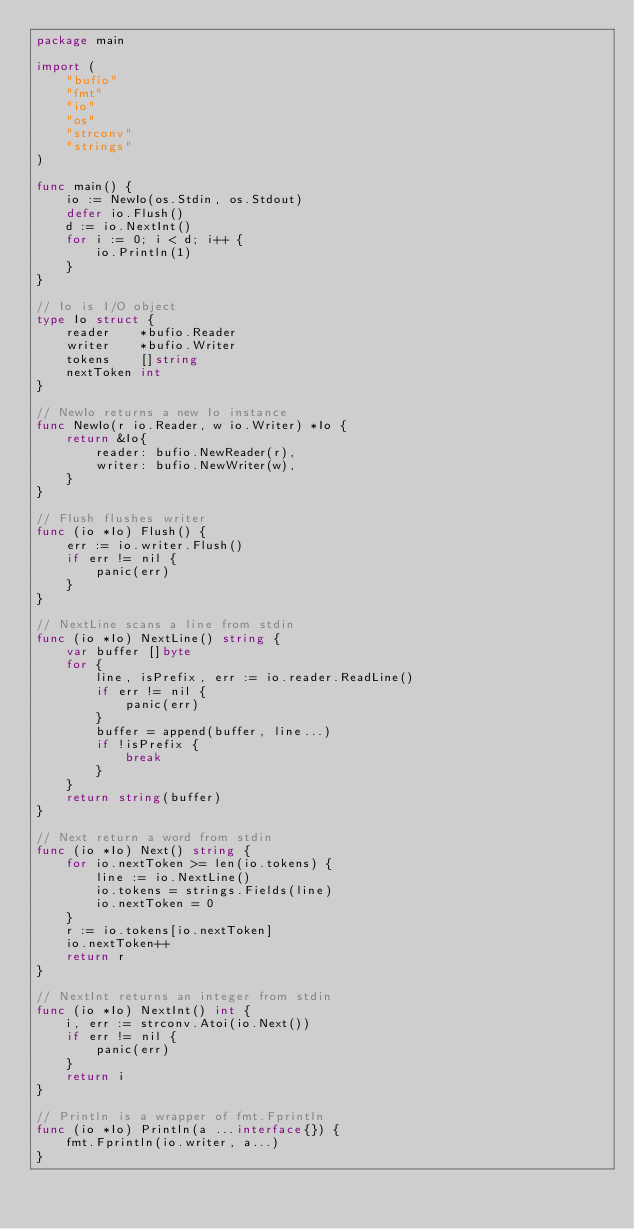Convert code to text. <code><loc_0><loc_0><loc_500><loc_500><_Go_>package main

import (
	"bufio"
	"fmt"
	"io"
	"os"
	"strconv"
	"strings"
)

func main() {
	io := NewIo(os.Stdin, os.Stdout)
	defer io.Flush()
	d := io.NextInt()
	for i := 0; i < d; i++ {
		io.Println(1)
	}
}

// Io is I/O object
type Io struct {
	reader    *bufio.Reader
	writer    *bufio.Writer
	tokens    []string
	nextToken int
}

// NewIo returns a new Io instance
func NewIo(r io.Reader, w io.Writer) *Io {
	return &Io{
		reader: bufio.NewReader(r),
		writer: bufio.NewWriter(w),
	}
}

// Flush flushes writer
func (io *Io) Flush() {
	err := io.writer.Flush()
	if err != nil {
		panic(err)
	}
}

// NextLine scans a line from stdin
func (io *Io) NextLine() string {
	var buffer []byte
	for {
		line, isPrefix, err := io.reader.ReadLine()
		if err != nil {
			panic(err)
		}
		buffer = append(buffer, line...)
		if !isPrefix {
			break
		}
	}
	return string(buffer)
}

// Next return a word from stdin
func (io *Io) Next() string {
	for io.nextToken >= len(io.tokens) {
		line := io.NextLine()
		io.tokens = strings.Fields(line)
		io.nextToken = 0
	}
	r := io.tokens[io.nextToken]
	io.nextToken++
	return r
}

// NextInt returns an integer from stdin
func (io *Io) NextInt() int {
	i, err := strconv.Atoi(io.Next())
	if err != nil {
		panic(err)
	}
	return i
}

// Println is a wrapper of fmt.Fprintln
func (io *Io) Println(a ...interface{}) {
	fmt.Fprintln(io.writer, a...)
}
</code> 